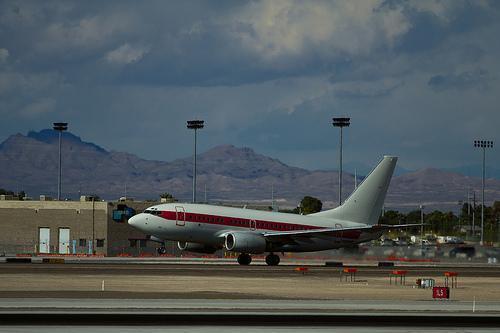How many planes are in photo?
Give a very brief answer. 1. 